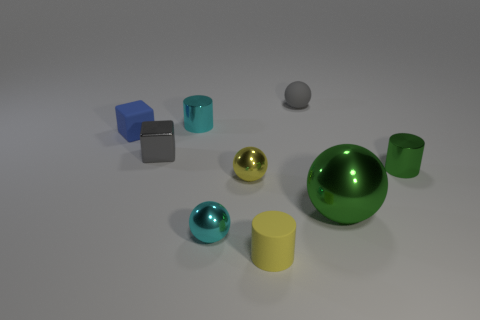What size is the metal object that is the same color as the small matte cylinder?
Your response must be concise. Small. What is the material of the blue thing behind the small yellow shiny thing?
Offer a terse response. Rubber. There is a rubber ball that is the same size as the yellow metallic object; what is its color?
Provide a short and direct response. Gray. What number of other objects are there of the same shape as the yellow matte object?
Provide a short and direct response. 2. Do the gray shiny block and the green ball have the same size?
Offer a terse response. No. Is the number of gray balls on the left side of the large green ball greater than the number of blue blocks to the right of the gray matte ball?
Keep it short and to the point. Yes. What number of other things are there of the same size as the cyan sphere?
Your answer should be compact. 7. There is a tiny sphere behind the small yellow sphere; does it have the same color as the small metallic block?
Make the answer very short. Yes. Is the number of yellow objects left of the small rubber cylinder greater than the number of brown rubber cylinders?
Ensure brevity in your answer.  Yes. Are there any other things of the same color as the small matte cube?
Provide a succinct answer. No. 